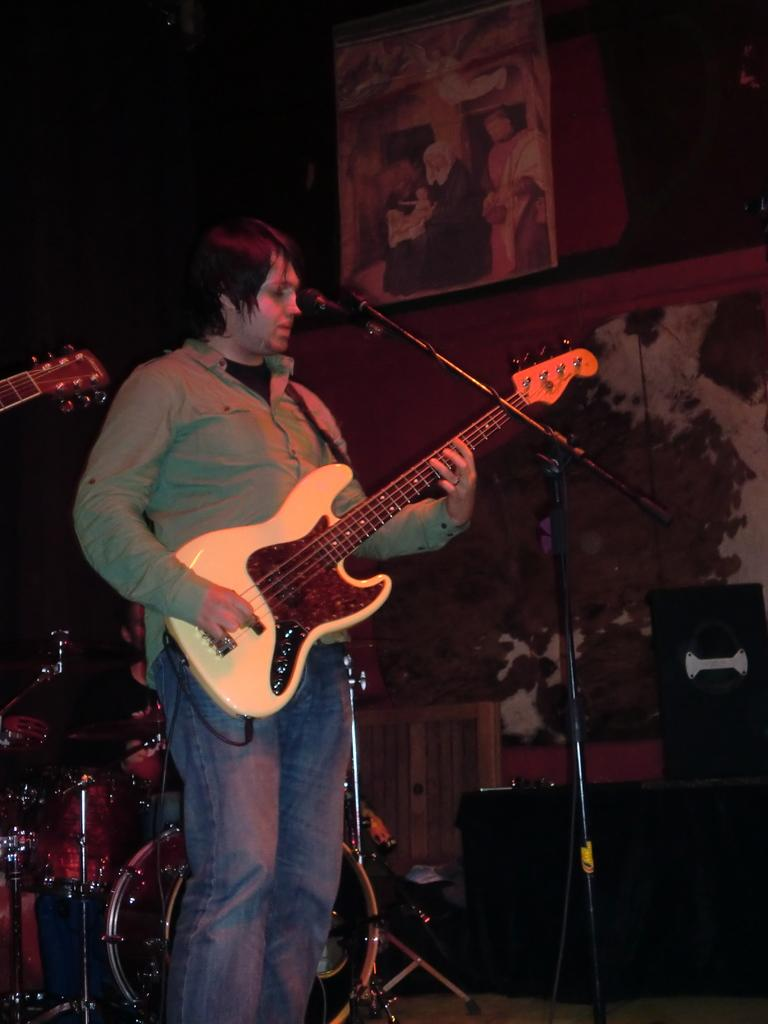What is the man in the image doing? The man is playing a guitar in the image. What object is present for amplifying sound? There is a microphone in the image. What can be seen on the wall in the image? There is a frame on the wall in the image. What other musical instruments are present in the image? There are musical instruments in the image, but the specific instruments are not mentioned in the facts. Can you describe the object in the background of the image? The facts only mention that there is an object in the background, but its description is not provided. What note is the actor playing on the hand in the image? There is no actor or hand mentioned in the image. The man is playing a guitar, but there is no mention of specific notes being played. 